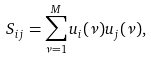Convert formula to latex. <formula><loc_0><loc_0><loc_500><loc_500>S _ { i j } = \sum _ { \nu = 1 } ^ { M } u _ { i } ( \nu ) u _ { j } ( \nu ) ,</formula> 